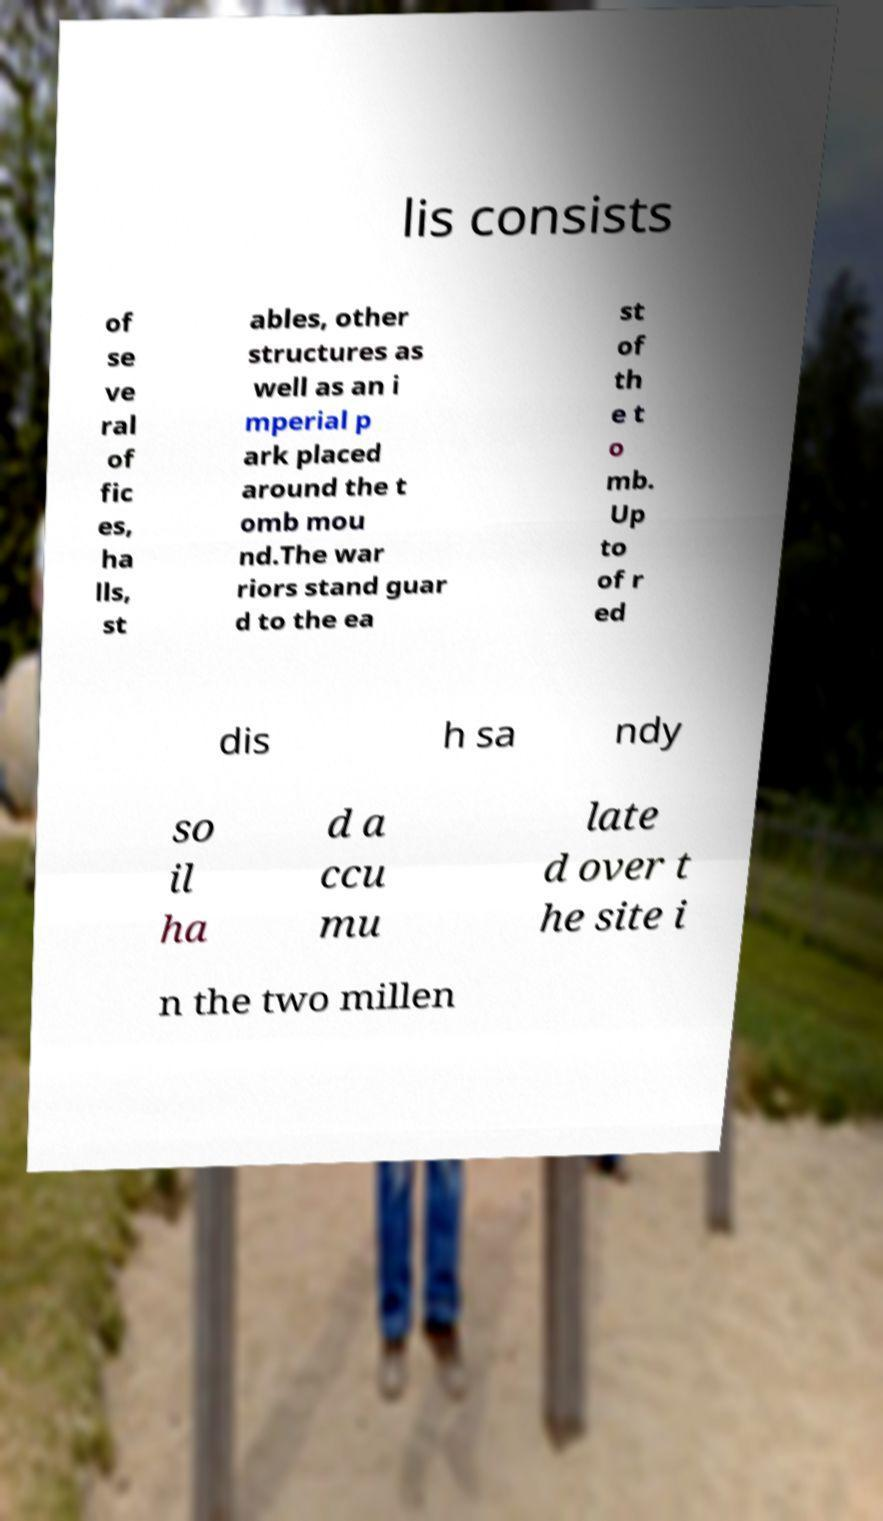Could you assist in decoding the text presented in this image and type it out clearly? lis consists of se ve ral of fic es, ha lls, st ables, other structures as well as an i mperial p ark placed around the t omb mou nd.The war riors stand guar d to the ea st of th e t o mb. Up to of r ed dis h sa ndy so il ha d a ccu mu late d over t he site i n the two millen 